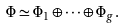Convert formula to latex. <formula><loc_0><loc_0><loc_500><loc_500>\Phi \simeq \Phi _ { 1 } \oplus \cdots \oplus \Phi _ { g } .</formula> 